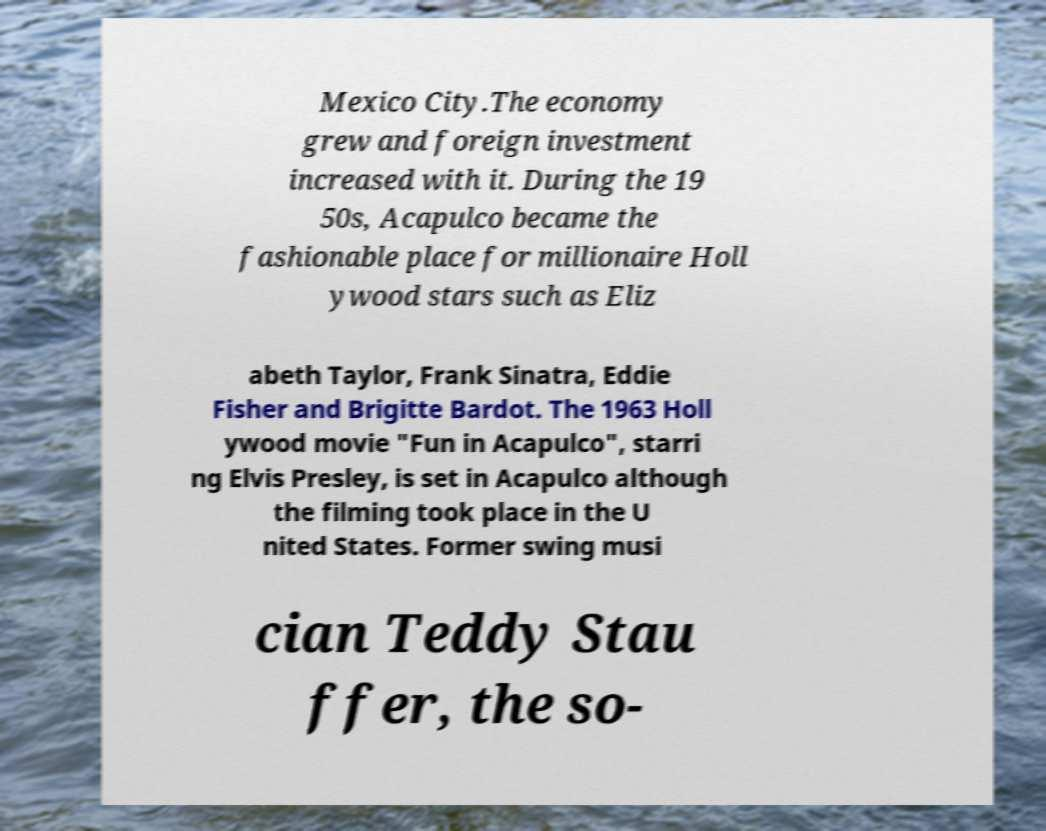Could you assist in decoding the text presented in this image and type it out clearly? Mexico City.The economy grew and foreign investment increased with it. During the 19 50s, Acapulco became the fashionable place for millionaire Holl ywood stars such as Eliz abeth Taylor, Frank Sinatra, Eddie Fisher and Brigitte Bardot. The 1963 Holl ywood movie "Fun in Acapulco", starri ng Elvis Presley, is set in Acapulco although the filming took place in the U nited States. Former swing musi cian Teddy Stau ffer, the so- 